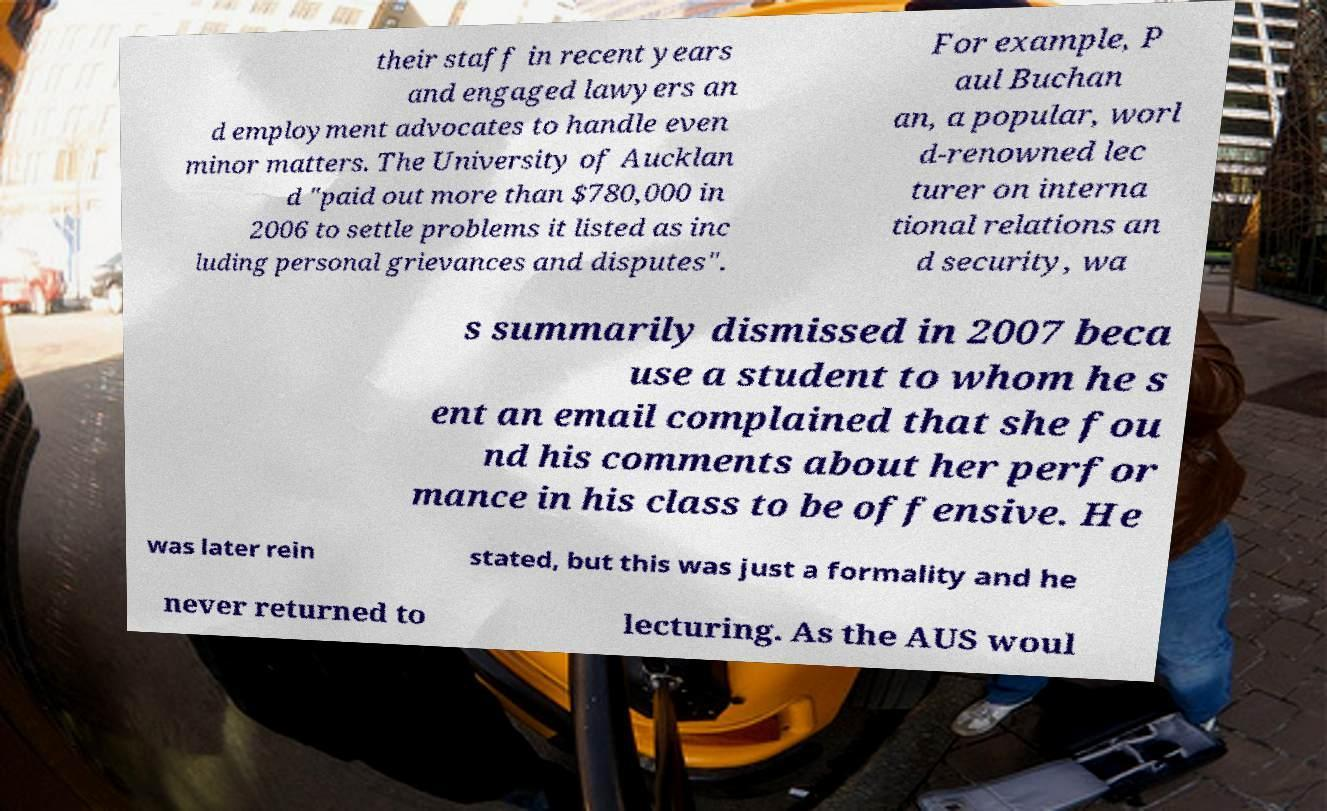What messages or text are displayed in this image? I need them in a readable, typed format. their staff in recent years and engaged lawyers an d employment advocates to handle even minor matters. The University of Aucklan d "paid out more than $780,000 in 2006 to settle problems it listed as inc luding personal grievances and disputes". For example, P aul Buchan an, a popular, worl d-renowned lec turer on interna tional relations an d security, wa s summarily dismissed in 2007 beca use a student to whom he s ent an email complained that she fou nd his comments about her perfor mance in his class to be offensive. He was later rein stated, but this was just a formality and he never returned to lecturing. As the AUS woul 